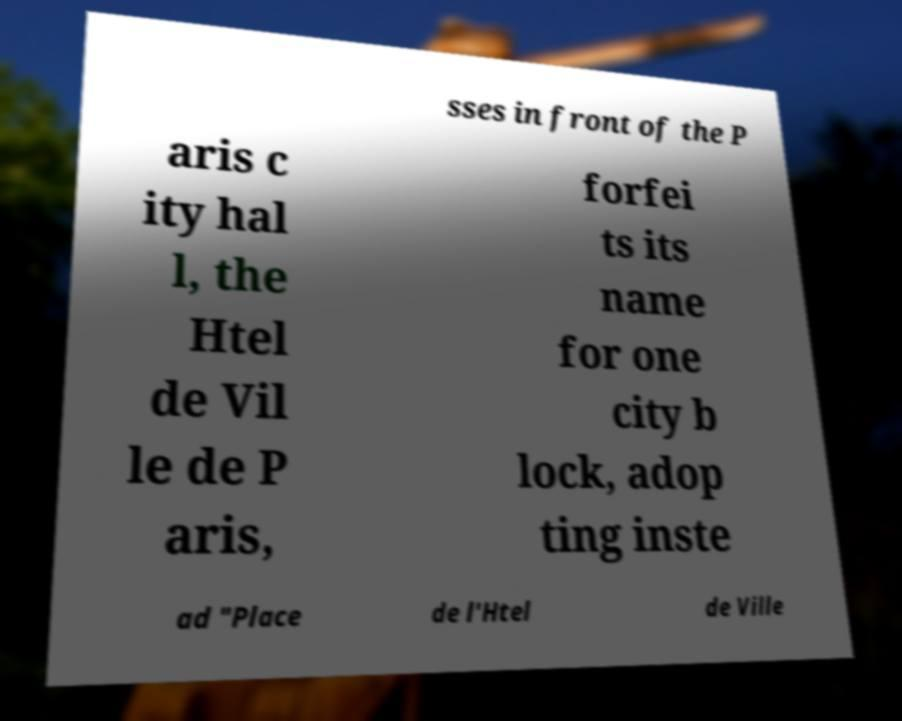Please identify and transcribe the text found in this image. sses in front of the P aris c ity hal l, the Htel de Vil le de P aris, forfei ts its name for one city b lock, adop ting inste ad "Place de l'Htel de Ville 